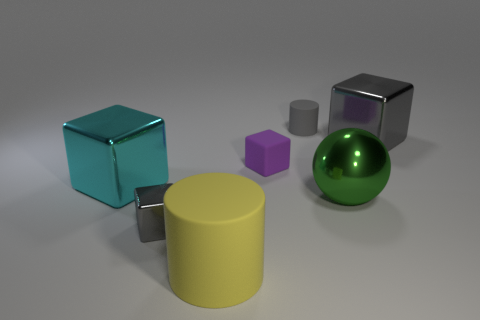Subtract all cyan cylinders. How many gray blocks are left? 2 Subtract 2 cubes. How many cubes are left? 2 Subtract all big gray blocks. How many blocks are left? 3 Subtract all cyan cubes. How many cubes are left? 3 Subtract all red cubes. Subtract all purple spheres. How many cubes are left? 4 Add 1 tiny purple spheres. How many objects exist? 8 Subtract all cylinders. How many objects are left? 5 Subtract all matte cylinders. Subtract all purple shiny things. How many objects are left? 5 Add 6 green balls. How many green balls are left? 7 Add 6 big rubber things. How many big rubber things exist? 7 